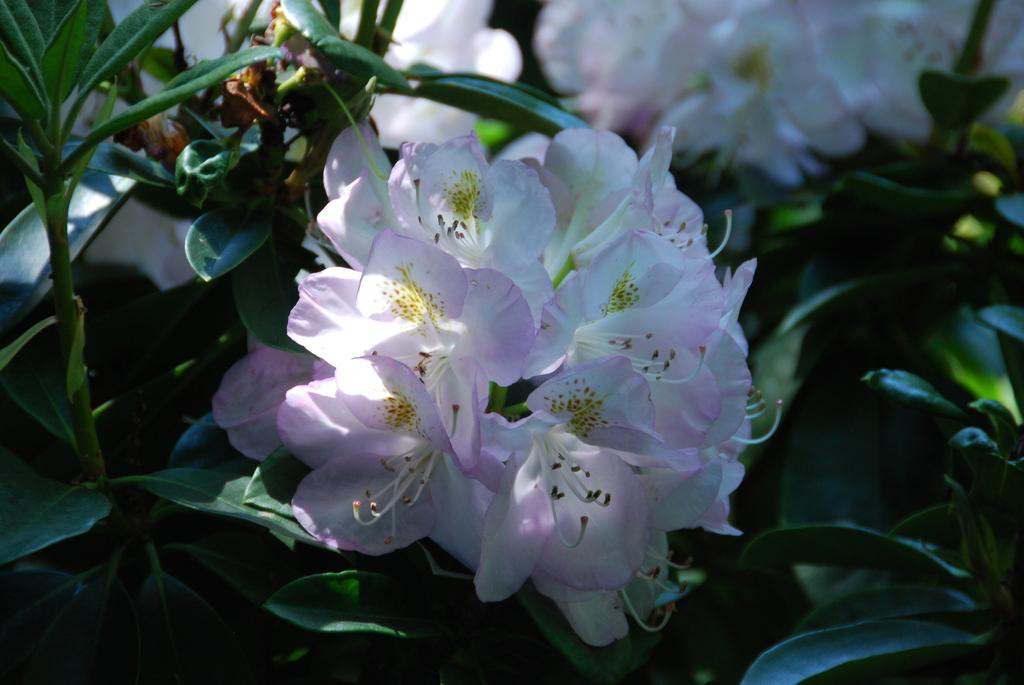What types of living organisms are present in the image? There is a group of plants and a group of flowers in the image. What colors can be seen in the flowers? The flowers are light pink and white in color. How much did the tax increase on the flowers in the image? There is no information about taxes in the image, as it features plants and flowers. 